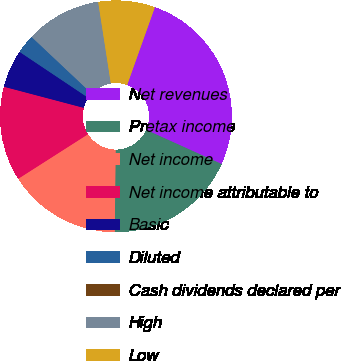Convert chart. <chart><loc_0><loc_0><loc_500><loc_500><pie_chart><fcel>Net revenues<fcel>Pretax income<fcel>Net income<fcel>Net income attributable to<fcel>Basic<fcel>Diluted<fcel>Cash dividends declared per<fcel>High<fcel>Low<nl><fcel>26.31%<fcel>18.42%<fcel>15.79%<fcel>13.16%<fcel>5.27%<fcel>2.64%<fcel>0.0%<fcel>10.53%<fcel>7.9%<nl></chart> 